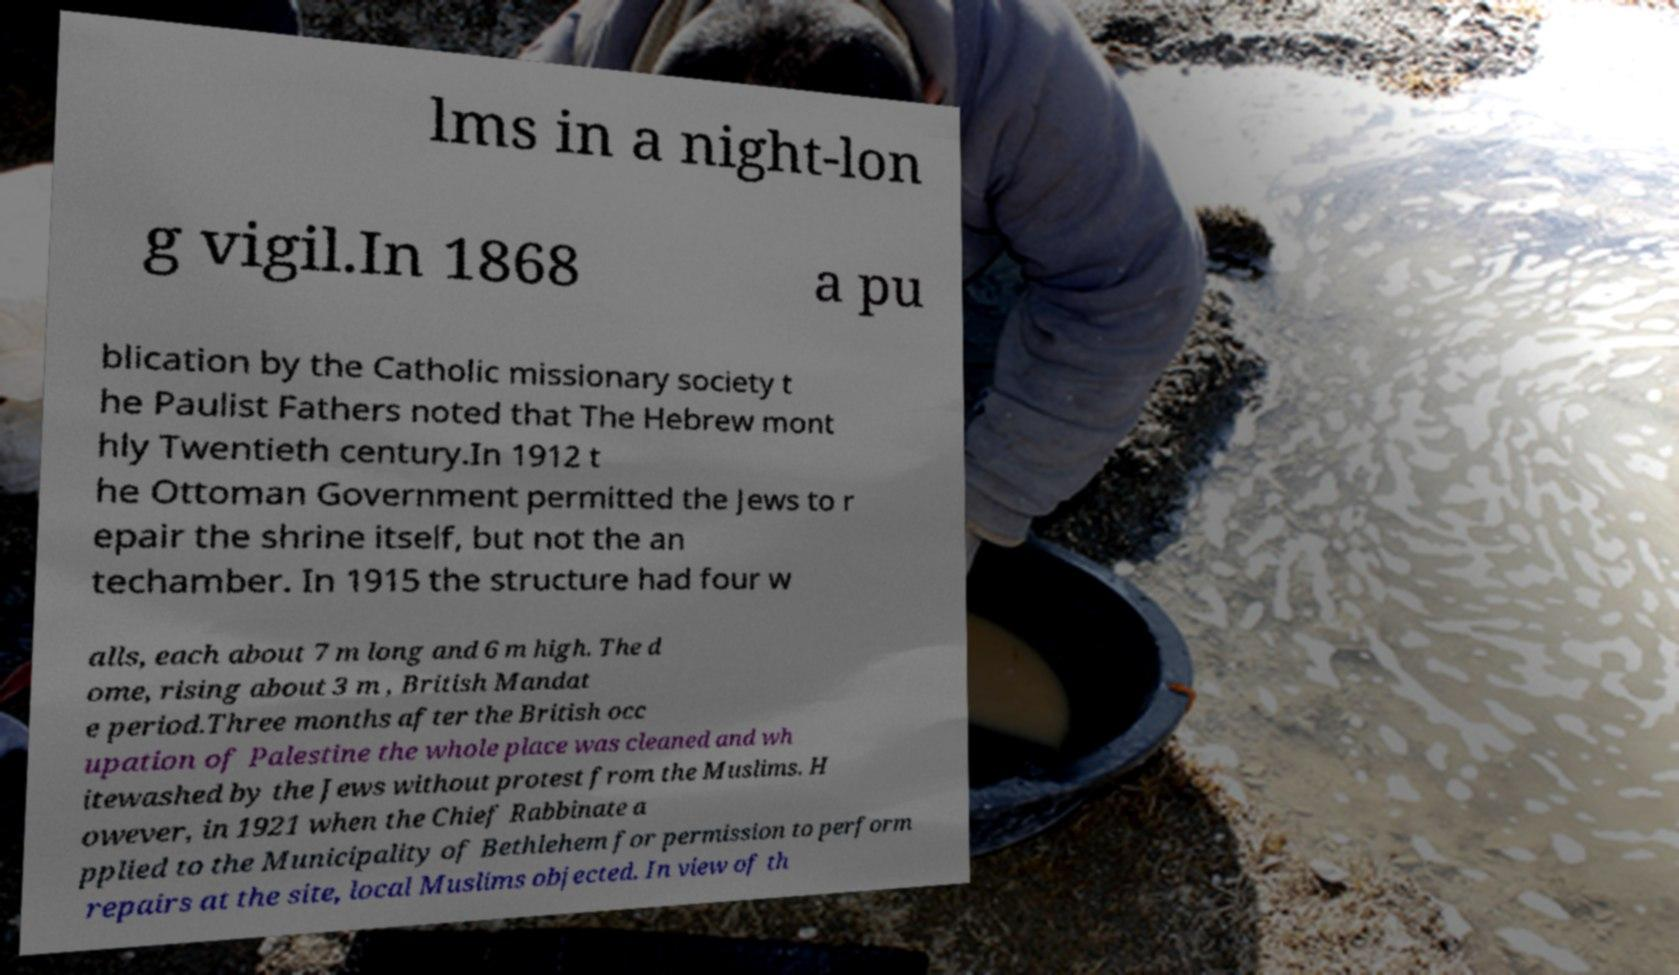For documentation purposes, I need the text within this image transcribed. Could you provide that? lms in a night-lon g vigil.In 1868 a pu blication by the Catholic missionary society t he Paulist Fathers noted that The Hebrew mont hly Twentieth century.In 1912 t he Ottoman Government permitted the Jews to r epair the shrine itself, but not the an techamber. In 1915 the structure had four w alls, each about 7 m long and 6 m high. The d ome, rising about 3 m , British Mandat e period.Three months after the British occ upation of Palestine the whole place was cleaned and wh itewashed by the Jews without protest from the Muslims. H owever, in 1921 when the Chief Rabbinate a pplied to the Municipality of Bethlehem for permission to perform repairs at the site, local Muslims objected. In view of th 